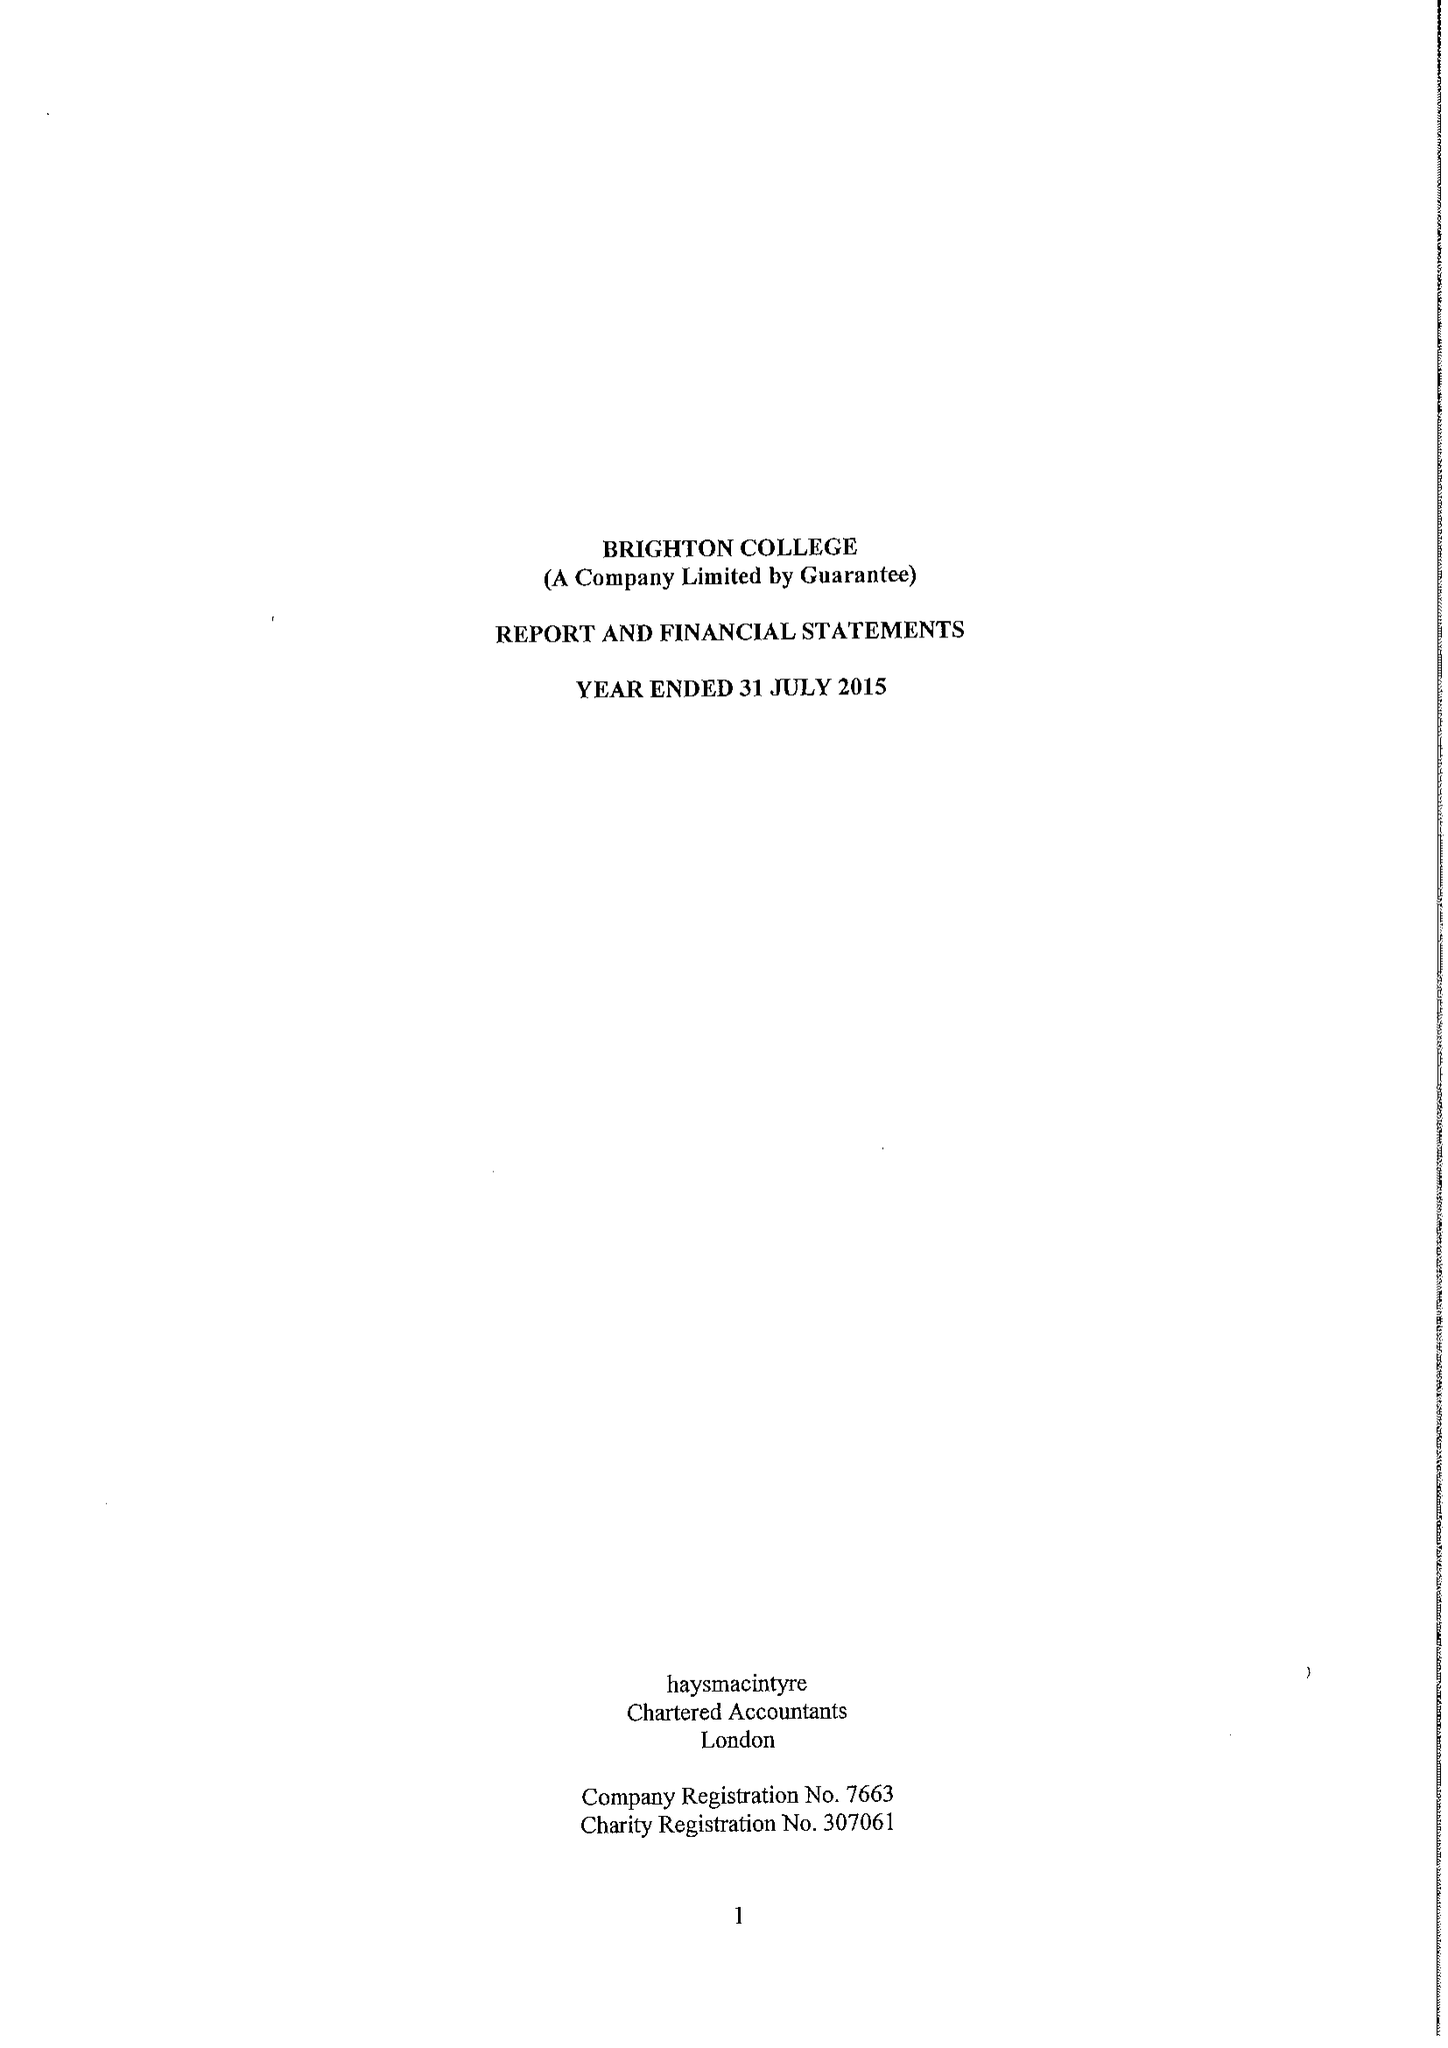What is the value for the address__postcode?
Answer the question using a single word or phrase. BN2 0AL 